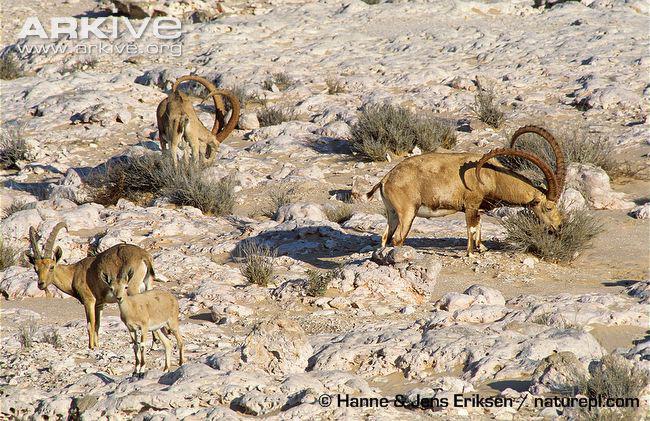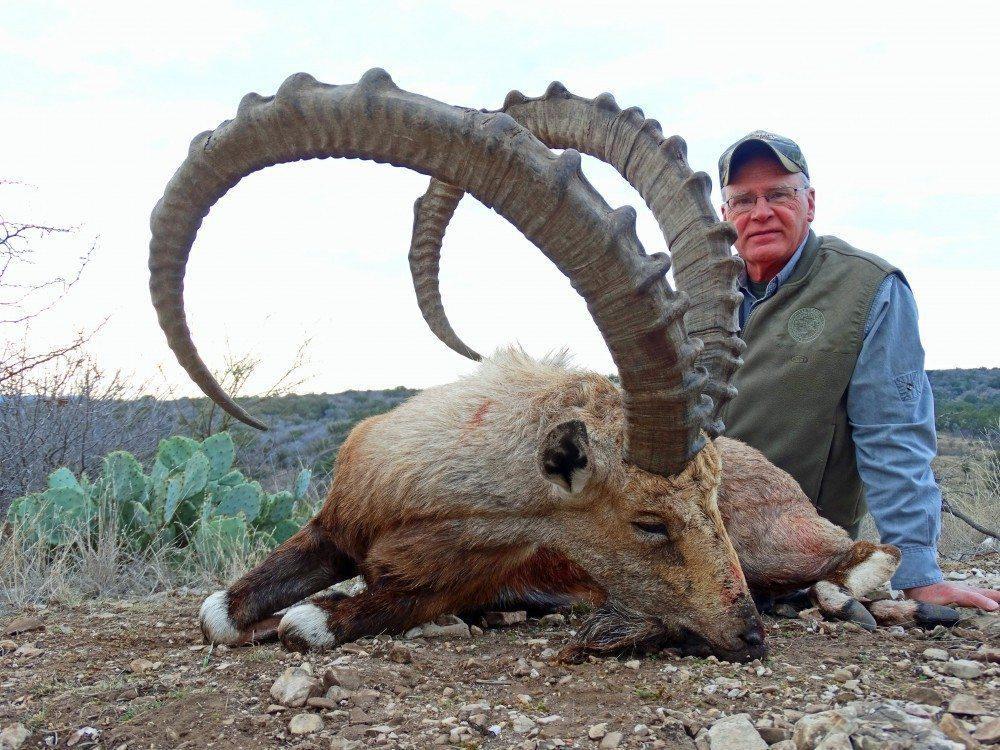The first image is the image on the left, the second image is the image on the right. For the images shown, is this caption "An image shows one man in a hat behind a downed animal, holding onto the tip of one horn with his hand." true? Answer yes or no. No. 